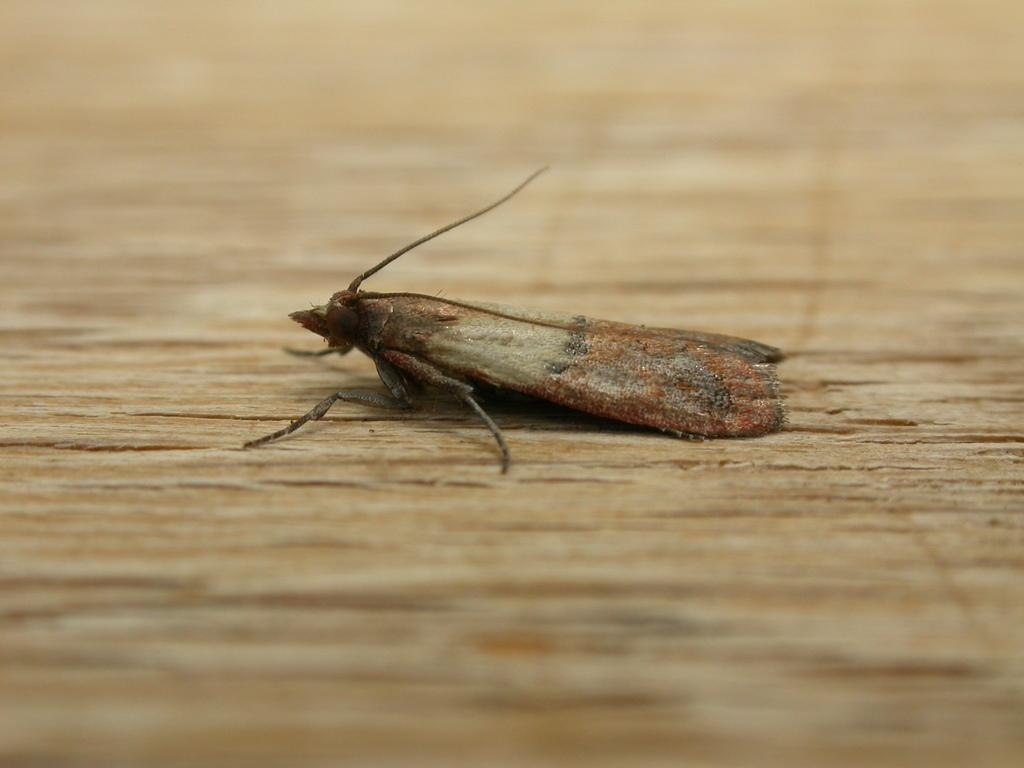What is the main subject in the center of the image? There is an insect in the center of the image. What type of material is the object at the bottom of the image? There is a wooden board at the bottom of the image. What type of journey is the judge embarking on in the image? There is no judge or journey present in the image; it features an insect and a wooden board. 